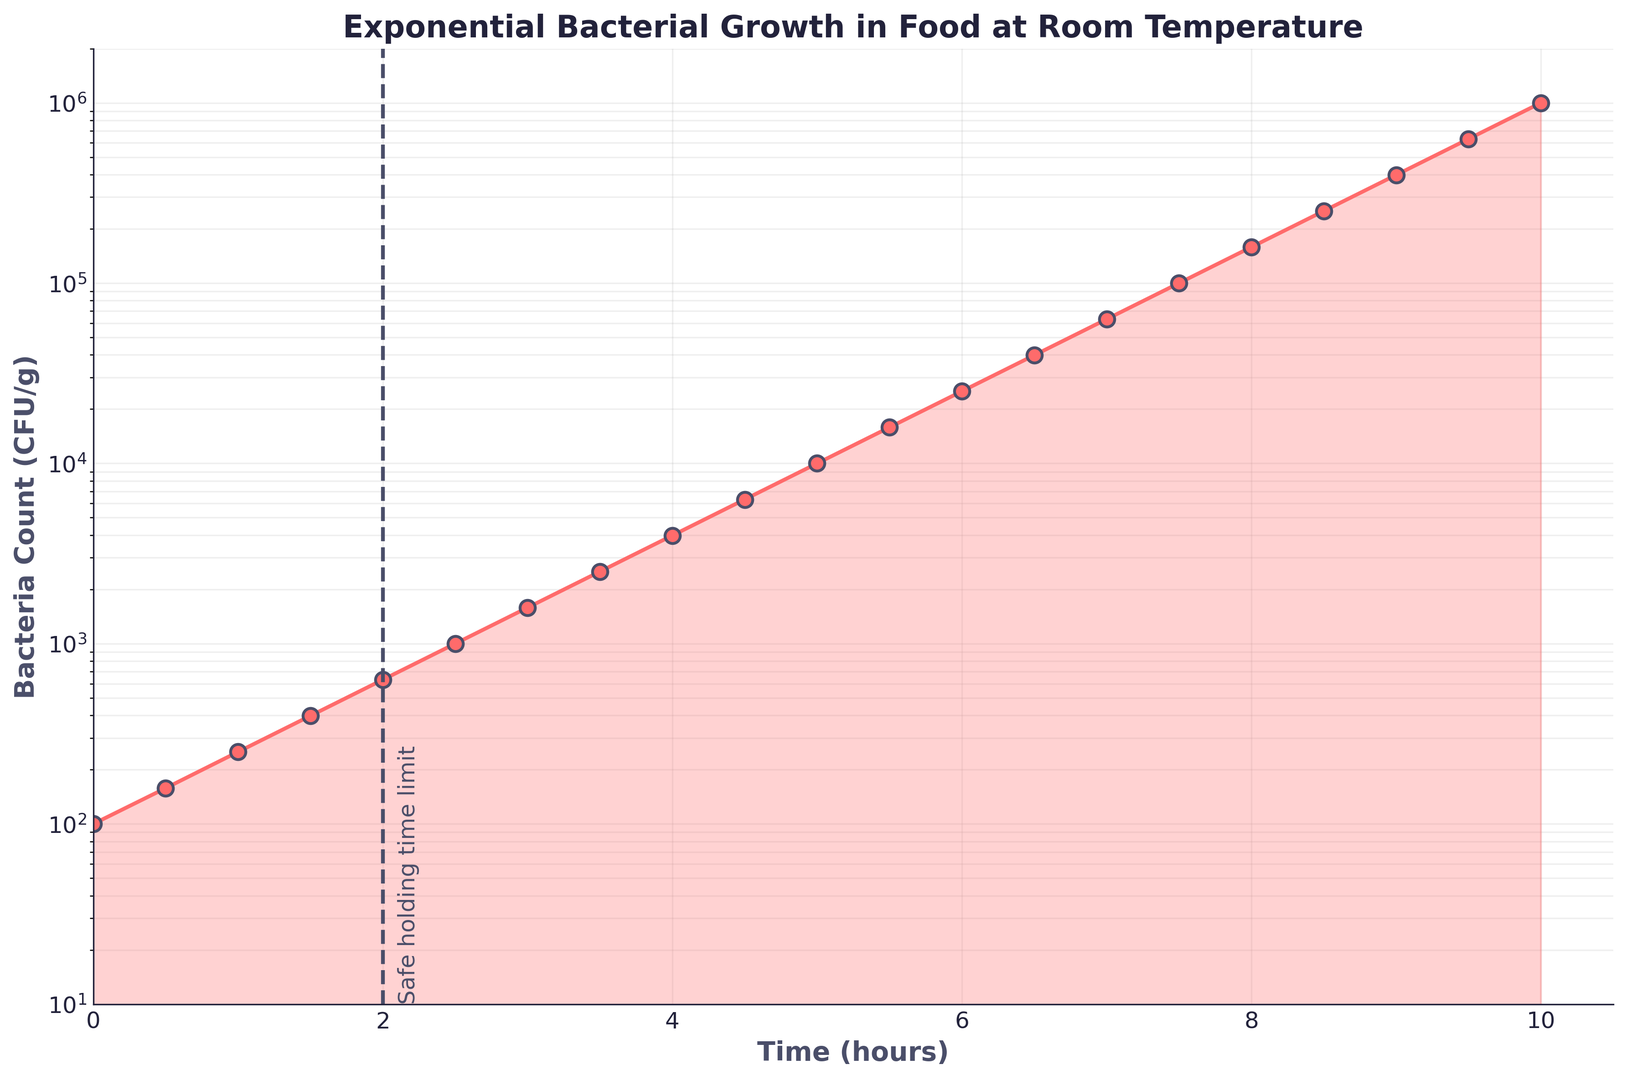What is the bacteria count at 5 hours? Refer to the point on the graph where the time is 5 hours and check the corresponding bacteria count on the y-axis.
Answer: 10,000 CFU/g At what time does the bacteria count first exceed 100,000 CFU/g? Identify the point where the bacteria count first crosses 100,000 CFU/g and look down at the corresponding time on the x-axis.
Answer: 7.5 hours How many times higher is the bacteria count at 8.5 hours compared to 2 hours? Find the bacteria counts at 8.5 hours and 2 hours. Divide the bacteria count at 8.5 hours (251,189 CFU/g) by the count at 2 hours (631 CFU/g).
Answer: 398 times What is the shape and color of the markers used to plot the data? Observe the type of markers used in the plot and their color.
Answer: Circular, red Which two time points have the steepest increase in bacteria count on the graph? Analyze the slope of the line segments connecting each pair of consecutive point. The steepest slope occurs where the increase is greatest.
Answer: Between 6 and 7 hours, and between 9 and 10 hours What does the dashed vertical line at 2 hours signify? The dashed vertical line is annotated with text indicating its significance.
Answer: Safe holding time limit If food is left at room temperature for 3.5 hours, should it be considered safe based on the safe holding time limit shown? Compare the time 3.5 hours with the 2-hour safe holding limit indicated by the dashed vertical line. 3.5 hours is beyond the 2-hour limit.
Answer: No By how much does the bacteria count increase from 0 to 2.5 hours? Determine the bacteria counts at 0 hours (100 CFU/g) and 2.5 hours (1,000 CFU/g). Subtract the initial count from the later count. 1,000 - 100 = 900 CFU/g.
Answer: 900 CFU/g What's the average bacteria count between 1 and 2 hours? Calculate the mean of the bacteria counts at 1 hour (251 CFU/g) and 2 hours (631 CFU/g). (251 + 631) / 2 = 441 CFU/g.
Answer: 441 CFU/g 